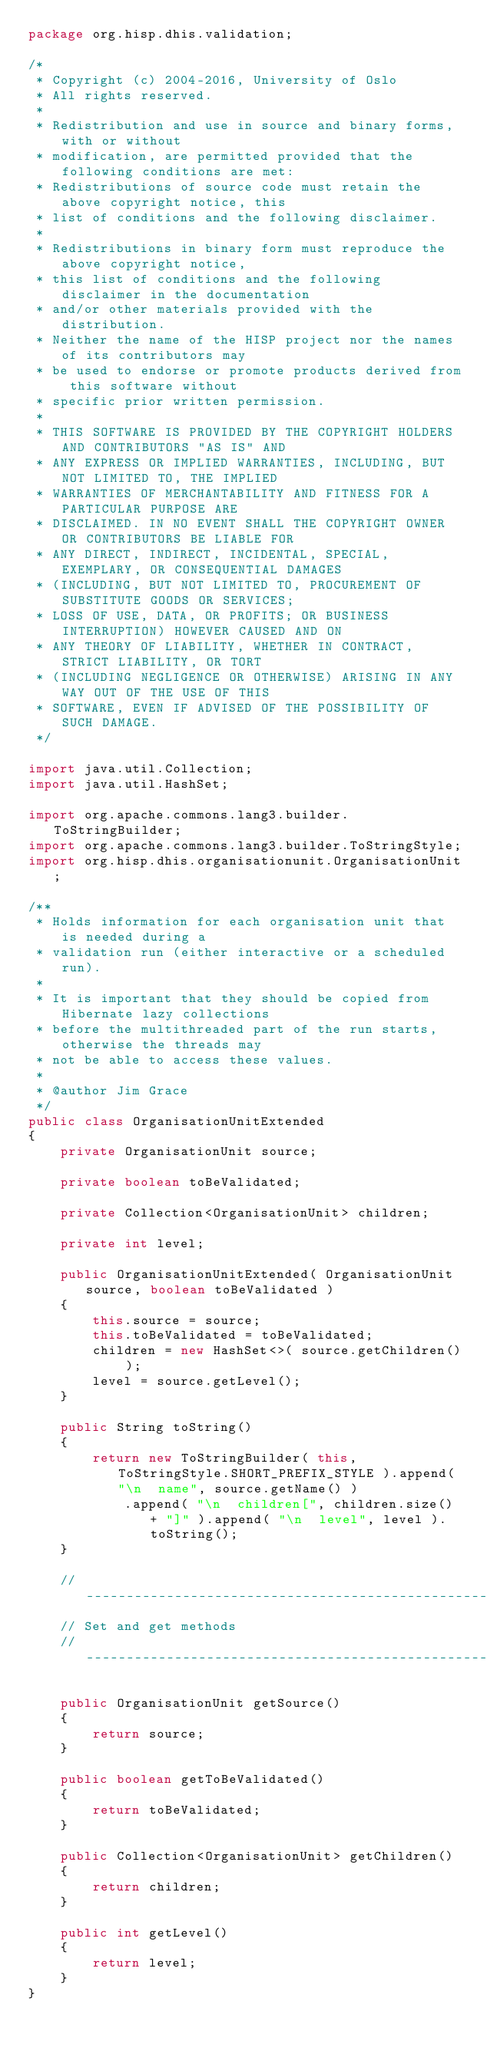<code> <loc_0><loc_0><loc_500><loc_500><_Java_>package org.hisp.dhis.validation;

/*
 * Copyright (c) 2004-2016, University of Oslo
 * All rights reserved.
 *
 * Redistribution and use in source and binary forms, with or without
 * modification, are permitted provided that the following conditions are met:
 * Redistributions of source code must retain the above copyright notice, this
 * list of conditions and the following disclaimer.
 *
 * Redistributions in binary form must reproduce the above copyright notice,
 * this list of conditions and the following disclaimer in the documentation
 * and/or other materials provided with the distribution.
 * Neither the name of the HISP project nor the names of its contributors may
 * be used to endorse or promote products derived from this software without
 * specific prior written permission.
 *
 * THIS SOFTWARE IS PROVIDED BY THE COPYRIGHT HOLDERS AND CONTRIBUTORS "AS IS" AND
 * ANY EXPRESS OR IMPLIED WARRANTIES, INCLUDING, BUT NOT LIMITED TO, THE IMPLIED
 * WARRANTIES OF MERCHANTABILITY AND FITNESS FOR A PARTICULAR PURPOSE ARE
 * DISCLAIMED. IN NO EVENT SHALL THE COPYRIGHT OWNER OR CONTRIBUTORS BE LIABLE FOR
 * ANY DIRECT, INDIRECT, INCIDENTAL, SPECIAL, EXEMPLARY, OR CONSEQUENTIAL DAMAGES
 * (INCLUDING, BUT NOT LIMITED TO, PROCUREMENT OF SUBSTITUTE GOODS OR SERVICES;
 * LOSS OF USE, DATA, OR PROFITS; OR BUSINESS INTERRUPTION) HOWEVER CAUSED AND ON
 * ANY THEORY OF LIABILITY, WHETHER IN CONTRACT, STRICT LIABILITY, OR TORT
 * (INCLUDING NEGLIGENCE OR OTHERWISE) ARISING IN ANY WAY OUT OF THE USE OF THIS
 * SOFTWARE, EVEN IF ADVISED OF THE POSSIBILITY OF SUCH DAMAGE.
 */

import java.util.Collection;
import java.util.HashSet;

import org.apache.commons.lang3.builder.ToStringBuilder;
import org.apache.commons.lang3.builder.ToStringStyle;
import org.hisp.dhis.organisationunit.OrganisationUnit;

/**
 * Holds information for each organisation unit that is needed during a
 * validation run (either interactive or a scheduled run).
 * 
 * It is important that they should be copied from Hibernate lazy collections
 * before the multithreaded part of the run starts, otherwise the threads may
 * not be able to access these values.
 * 
 * @author Jim Grace
 */
public class OrganisationUnitExtended
{
    private OrganisationUnit source;

    private boolean toBeValidated;

    private Collection<OrganisationUnit> children;

    private int level;

    public OrganisationUnitExtended( OrganisationUnit source, boolean toBeValidated )
    {
        this.source = source;
        this.toBeValidated = toBeValidated;
        children = new HashSet<>( source.getChildren() );
        level = source.getLevel();
    }

    public String toString()
    {
        return new ToStringBuilder( this, ToStringStyle.SHORT_PREFIX_STYLE ).append( "\n  name", source.getName() )
            .append( "\n  children[", children.size() + "]" ).append( "\n  level", level ).toString();
    }

    // -------------------------------------------------------------------------
    // Set and get methods
    // -------------------------------------------------------------------------

    public OrganisationUnit getSource()
    {
        return source;
    }

    public boolean getToBeValidated()
    {
        return toBeValidated;
    }

    public Collection<OrganisationUnit> getChildren()
    {
        return children;
    }

    public int getLevel()
    {
        return level;
    }
}
</code> 